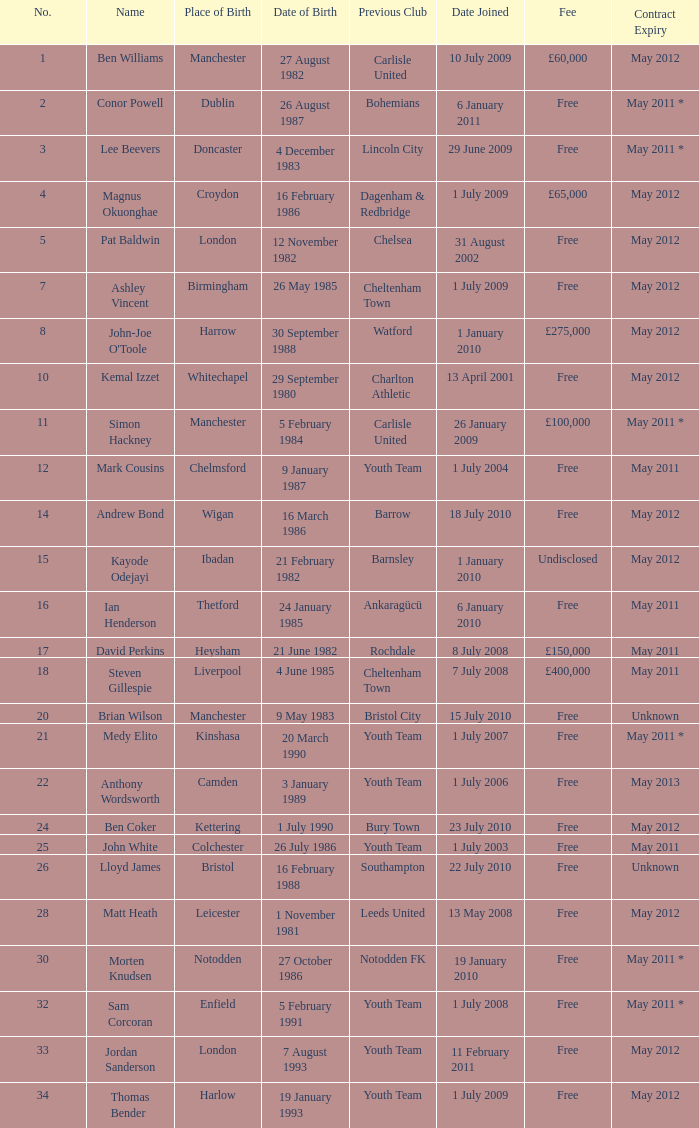What is the count of birthdates if the earlier club is chelsea? 1.0. 